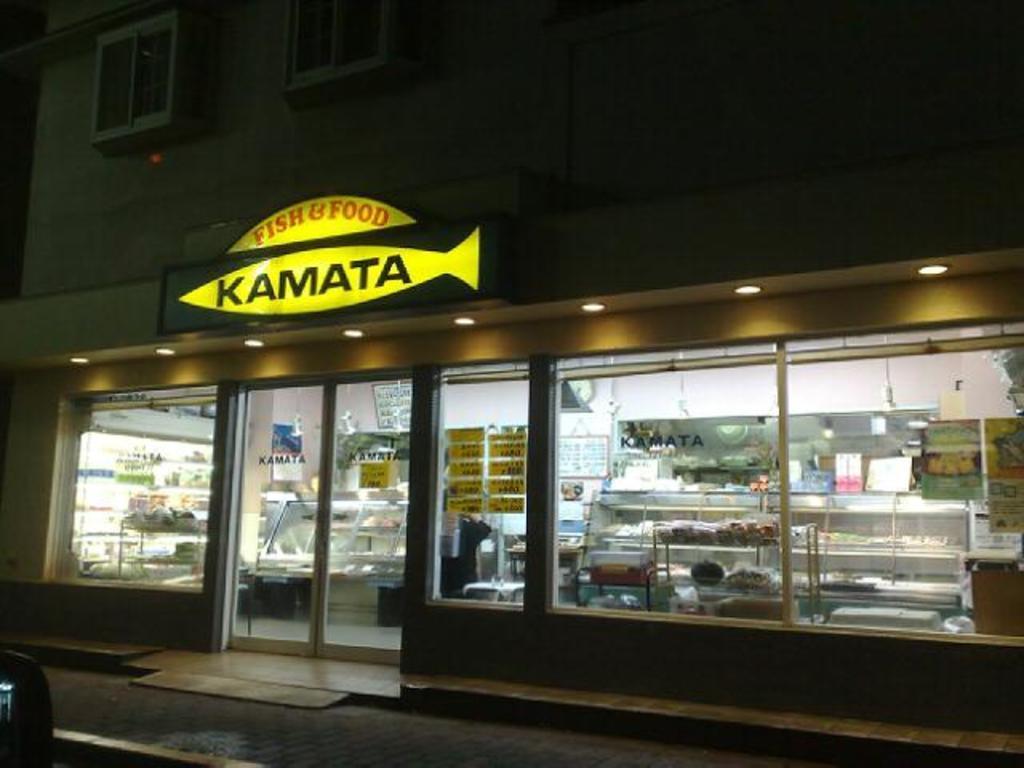Describe this image in one or two sentences. In this picture, there is a building. In the building, there is a store. On the building there is a board with some text. In the store, there are racks and some objects. At the bottom, there is a road. 